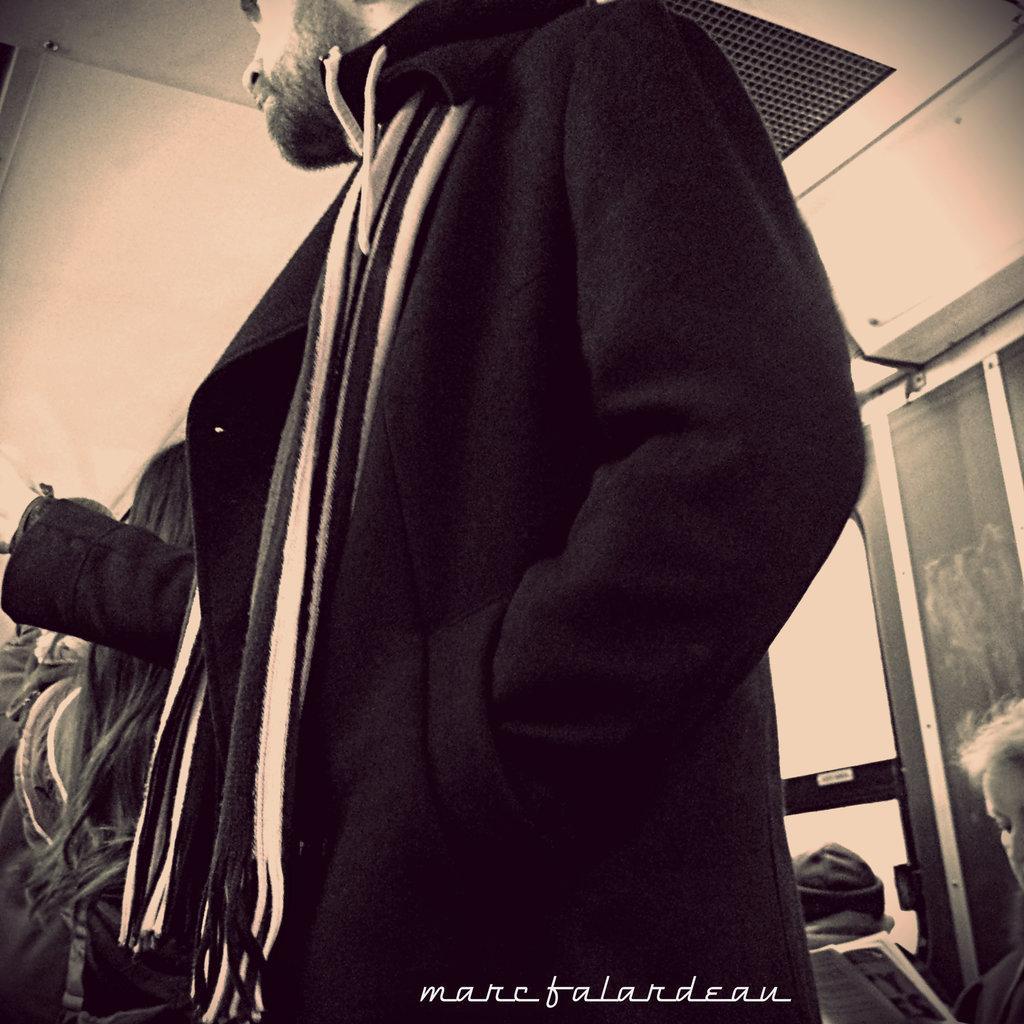Could you give a brief overview of what you see in this image? In this image there are group of persons standing and sitting. There is a window on the right side and there is a door which is white in colour. 